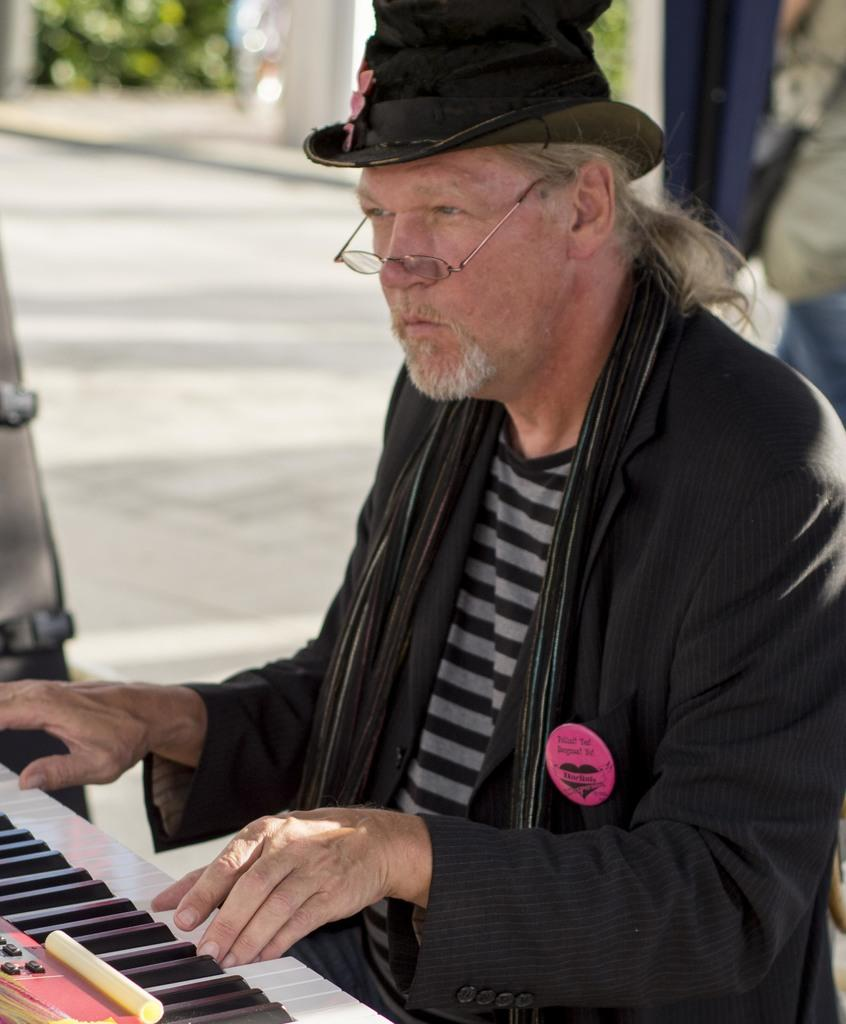What is the main subject of the image? The main subject of the image is a man. What is the man doing in the image? The man is playing a musical keyboard. What type of crush can be seen in the image? There is no crush present in the image. What type of snow can be seen falling in the image? There is no snow present in the image. What type of carpentry tools can be seen in the image? There is no carpentry tools present in the image. 